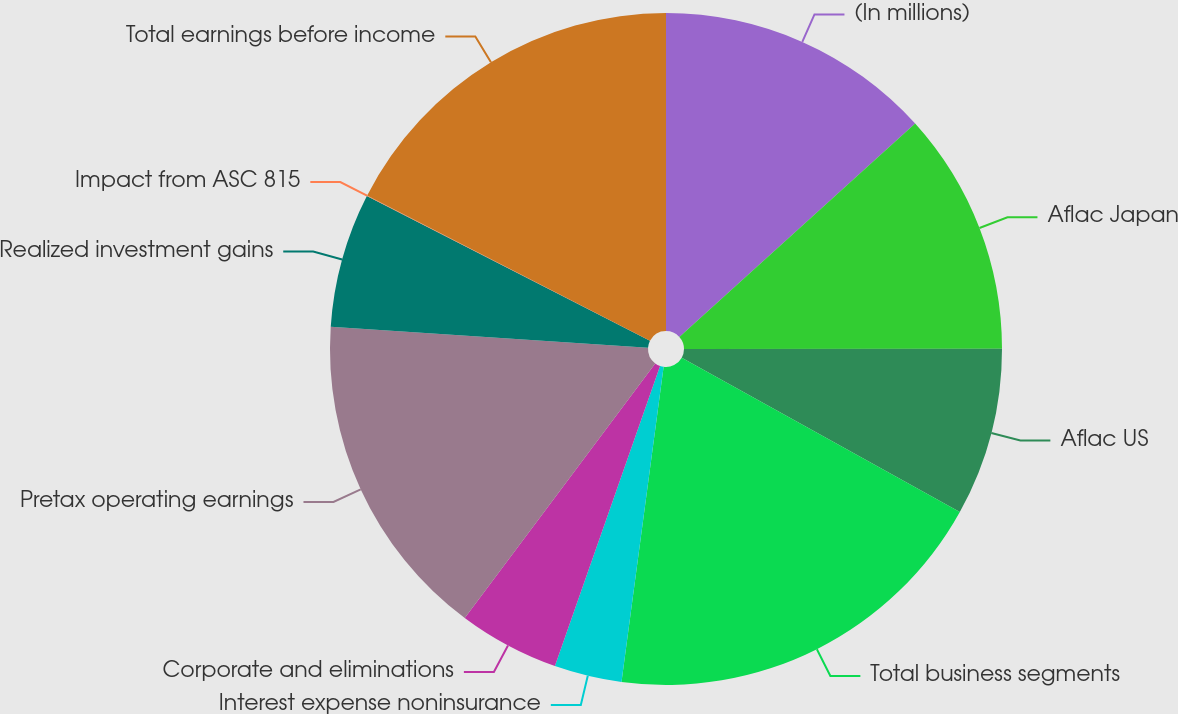Convert chart to OTSL. <chart><loc_0><loc_0><loc_500><loc_500><pie_chart><fcel>(In millions)<fcel>Aflac Japan<fcel>Aflac US<fcel>Total business segments<fcel>Interest expense noninsurance<fcel>Corporate and eliminations<fcel>Pretax operating earnings<fcel>Realized investment gains<fcel>Impact from ASC 815<fcel>Total earnings before income<nl><fcel>13.3%<fcel>11.69%<fcel>8.08%<fcel>19.06%<fcel>3.25%<fcel>4.86%<fcel>15.84%<fcel>6.47%<fcel>0.03%<fcel>17.45%<nl></chart> 